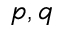Convert formula to latex. <formula><loc_0><loc_0><loc_500><loc_500>p , q</formula> 